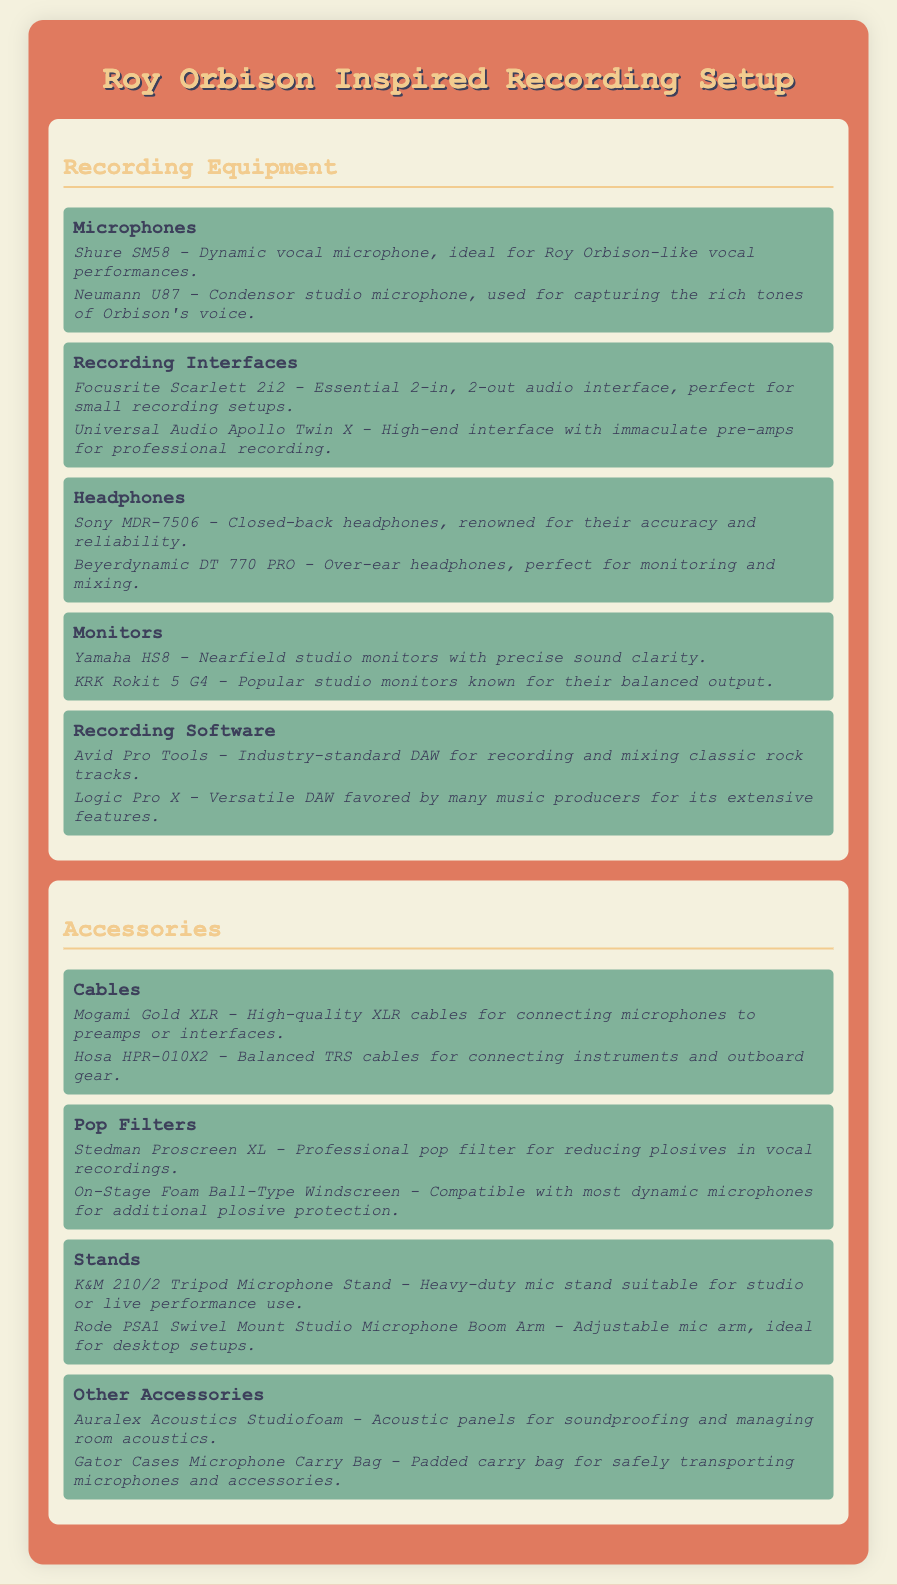What microphones are listed? The section on microphones provides the specific types and models that are relevant to the recording setup, which are Shure SM58 and Neumann U87.
Answer: Shure SM58, Neumann U87 What is the purpose of the Focusrite Scarlett 2i2? The Focusrite Scarlett 2i2 is mentioned as an essential audio interface, specifically noted for small recording setups.
Answer: Small recording setups Which headphones are recommended for monitoring? The document identifies Beyerdynamic DT 770 PRO as a suitable headphone for monitoring and mixing.
Answer: Beyerdynamic DT 770 PRO How many different types of recording software are mentioned? Two types of recording software are highlighted in the section on software: Avid Pro Tools and Logic Pro X.
Answer: Two What is the primary function of the Stedman Proscreen XL? The note on the Stedman Proscreen XL specifies its role in reducing plosives during vocal recordings.
Answer: Reducing plosives Which microphone stand is described as heavy-duty? The document lists K&M 210/2 Tripod Microphone Stand as a heavy-duty option suitable for various uses.
Answer: K&M 210/2 Tripod Microphone Stand How many categories of equipment are included in the packing list? The packing list contains two main categories: Recording Equipment and Accessories.
Answer: Two What type of cable is the Mogami Gold XLR? The Mogami Gold XLR cable is specified as a high-quality XLR cable for connecting microphones to gear.
Answer: High-quality XLR cable 